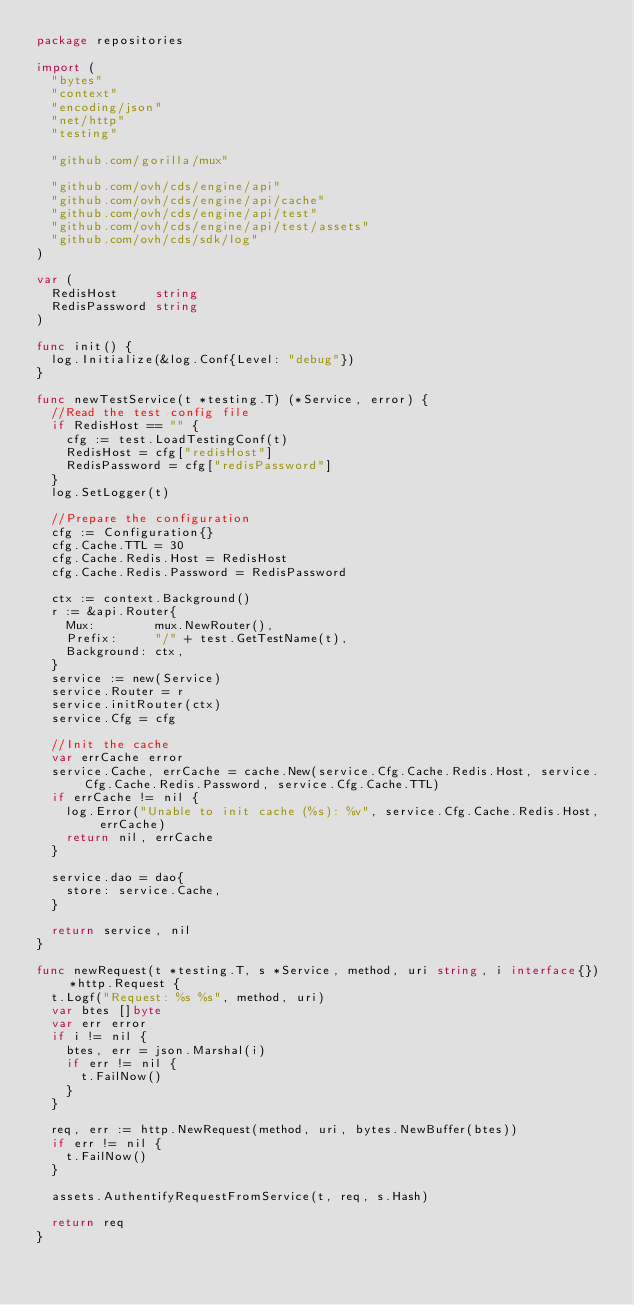<code> <loc_0><loc_0><loc_500><loc_500><_Go_>package repositories

import (
	"bytes"
	"context"
	"encoding/json"
	"net/http"
	"testing"

	"github.com/gorilla/mux"

	"github.com/ovh/cds/engine/api"
	"github.com/ovh/cds/engine/api/cache"
	"github.com/ovh/cds/engine/api/test"
	"github.com/ovh/cds/engine/api/test/assets"
	"github.com/ovh/cds/sdk/log"
)

var (
	RedisHost     string
	RedisPassword string
)

func init() {
	log.Initialize(&log.Conf{Level: "debug"})
}

func newTestService(t *testing.T) (*Service, error) {
	//Read the test config file
	if RedisHost == "" {
		cfg := test.LoadTestingConf(t)
		RedisHost = cfg["redisHost"]
		RedisPassword = cfg["redisPassword"]
	}
	log.SetLogger(t)

	//Prepare the configuration
	cfg := Configuration{}
	cfg.Cache.TTL = 30
	cfg.Cache.Redis.Host = RedisHost
	cfg.Cache.Redis.Password = RedisPassword

	ctx := context.Background()
	r := &api.Router{
		Mux:        mux.NewRouter(),
		Prefix:     "/" + test.GetTestName(t),
		Background: ctx,
	}
	service := new(Service)
	service.Router = r
	service.initRouter(ctx)
	service.Cfg = cfg

	//Init the cache
	var errCache error
	service.Cache, errCache = cache.New(service.Cfg.Cache.Redis.Host, service.Cfg.Cache.Redis.Password, service.Cfg.Cache.TTL)
	if errCache != nil {
		log.Error("Unable to init cache (%s): %v", service.Cfg.Cache.Redis.Host, errCache)
		return nil, errCache
	}

	service.dao = dao{
		store: service.Cache,
	}

	return service, nil
}

func newRequest(t *testing.T, s *Service, method, uri string, i interface{}) *http.Request {
	t.Logf("Request: %s %s", method, uri)
	var btes []byte
	var err error
	if i != nil {
		btes, err = json.Marshal(i)
		if err != nil {
			t.FailNow()
		}
	}

	req, err := http.NewRequest(method, uri, bytes.NewBuffer(btes))
	if err != nil {
		t.FailNow()
	}

	assets.AuthentifyRequestFromService(t, req, s.Hash)

	return req
}
</code> 